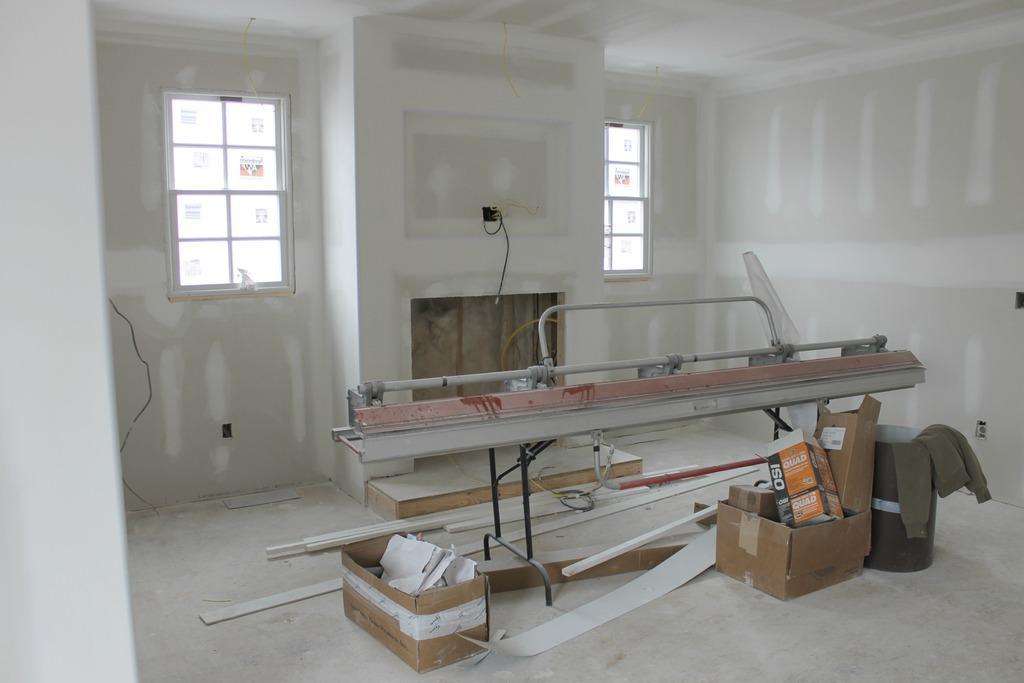Can you describe this image briefly? In this image we can see the inner view of a room. In the room there are machine on the stand, cardboard cartons, wooden bars, sweater, windows and cables. 